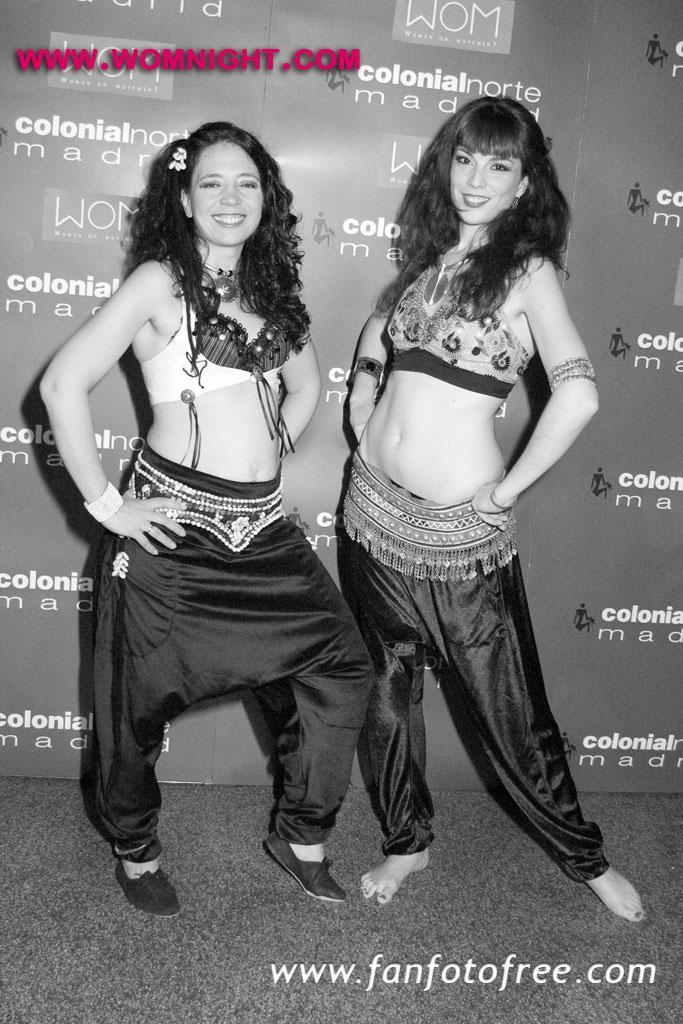How would you summarize this image in a sentence or two? In this image I can see two persons standing and smiling. There is a board in the background. At the top and bottom of the image there are watermarks. 